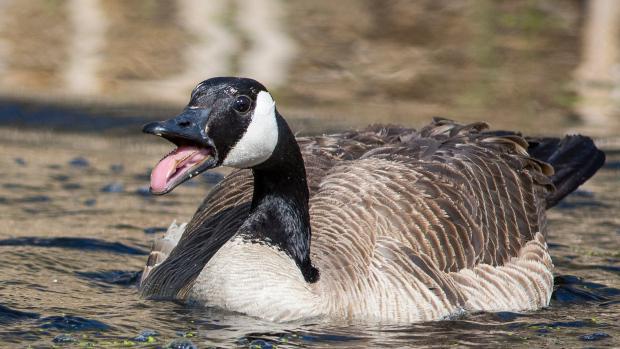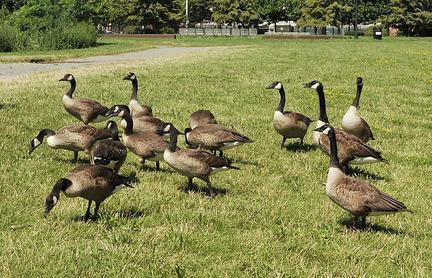The first image is the image on the left, the second image is the image on the right. Assess this claim about the two images: "Exactly two Canada geese are in or near a body of water.". Correct or not? Answer yes or no. No. The first image is the image on the left, the second image is the image on the right. Examine the images to the left and right. Is the description "One of the images shows exactly two geese." accurate? Answer yes or no. No. 